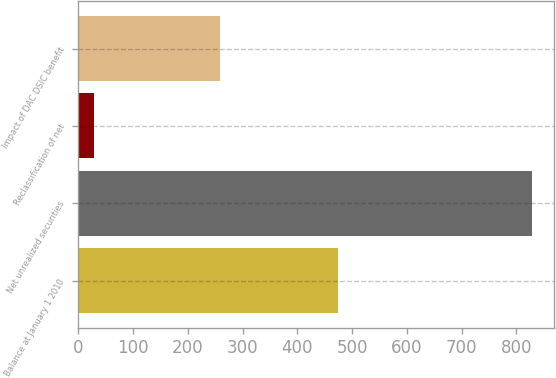Convert chart to OTSL. <chart><loc_0><loc_0><loc_500><loc_500><bar_chart><fcel>Balance at January 1 2010<fcel>Net unrealized securities<fcel>Reclassification of net<fcel>Impact of DAC DSIC benefit<nl><fcel>474<fcel>828<fcel>28<fcel>259<nl></chart> 